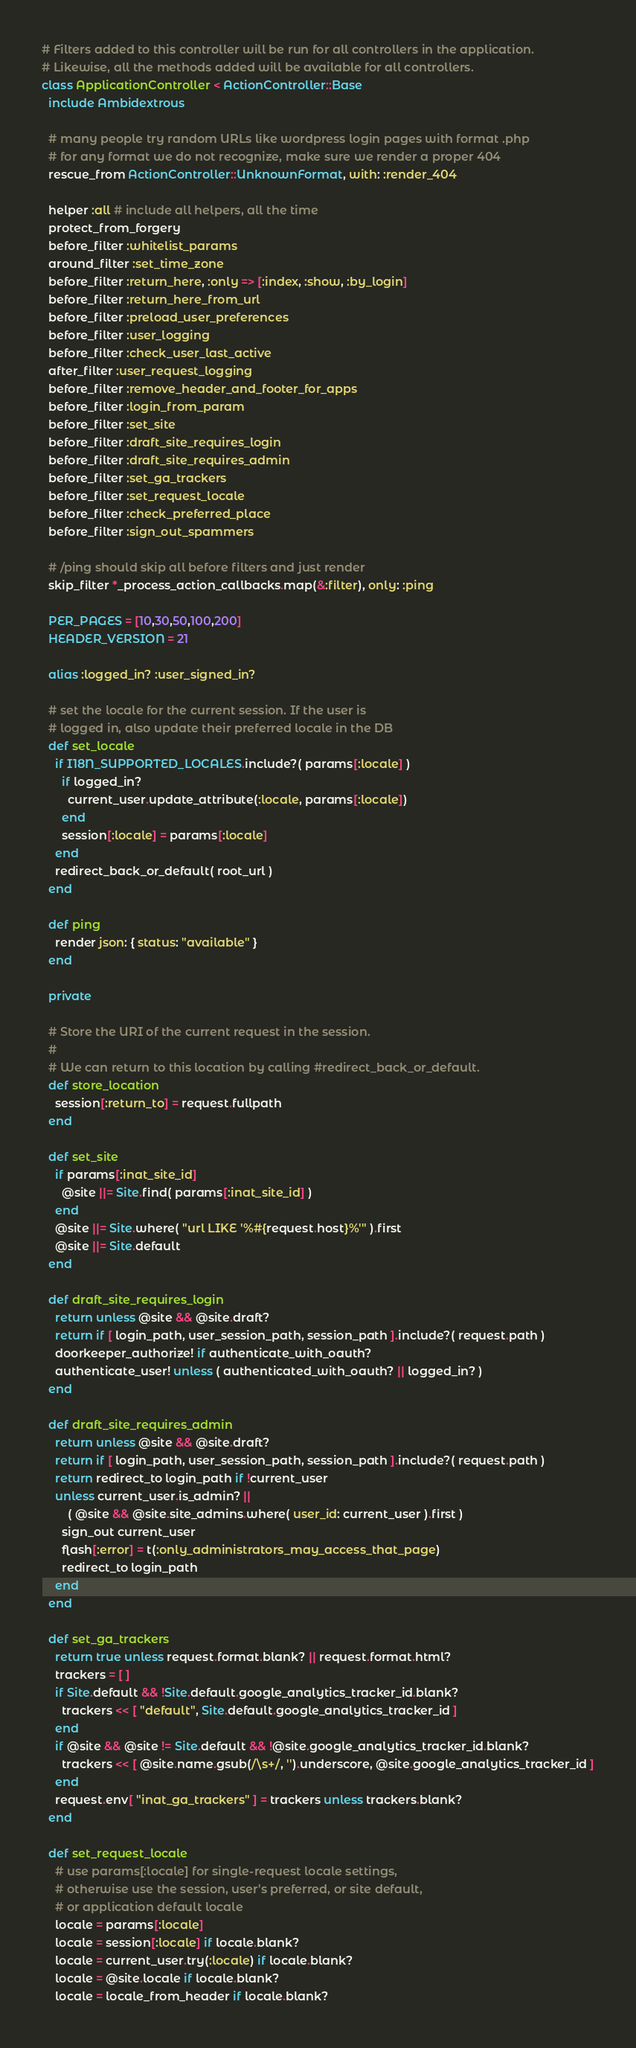Convert code to text. <code><loc_0><loc_0><loc_500><loc_500><_Ruby_># Filters added to this controller will be run for all controllers in the application.
# Likewise, all the methods added will be available for all controllers.
class ApplicationController < ActionController::Base
  include Ambidextrous

  # many people try random URLs like wordpress login pages with format .php
  # for any format we do not recognize, make sure we render a proper 404
  rescue_from ActionController::UnknownFormat, with: :render_404

  helper :all # include all helpers, all the time
  protect_from_forgery
  before_filter :whitelist_params
  around_filter :set_time_zone
  before_filter :return_here, :only => [:index, :show, :by_login]
  before_filter :return_here_from_url
  before_filter :preload_user_preferences
  before_filter :user_logging
  before_filter :check_user_last_active
  after_filter :user_request_logging
  before_filter :remove_header_and_footer_for_apps
  before_filter :login_from_param
  before_filter :set_site
  before_filter :draft_site_requires_login
  before_filter :draft_site_requires_admin
  before_filter :set_ga_trackers
  before_filter :set_request_locale
  before_filter :check_preferred_place
  before_filter :sign_out_spammers

  # /ping should skip all before filters and just render
  skip_filter *_process_action_callbacks.map(&:filter), only: :ping

  PER_PAGES = [10,30,50,100,200]
  HEADER_VERSION = 21
  
  alias :logged_in? :user_signed_in?

  # set the locale for the current session. If the user is
  # logged in, also update their preferred locale in the DB
  def set_locale
    if I18N_SUPPORTED_LOCALES.include?( params[:locale] )
      if logged_in?
        current_user.update_attribute(:locale, params[:locale])
      end
      session[:locale] = params[:locale]
    end
    redirect_back_or_default( root_url )
  end

  def ping
    render json: { status: "available" }
  end

  private

  # Store the URI of the current request in the session.
  #
  # We can return to this location by calling #redirect_back_or_default.
  def store_location
    session[:return_to] = request.fullpath
  end

  def set_site
    if params[:inat_site_id]
      @site ||= Site.find( params[:inat_site_id] )
    end
    @site ||= Site.where( "url LIKE '%#{request.host}%'" ).first
    @site ||= Site.default
  end

  def draft_site_requires_login
    return unless @site && @site.draft?
    return if [ login_path, user_session_path, session_path ].include?( request.path )
    doorkeeper_authorize! if authenticate_with_oauth?
    authenticate_user! unless ( authenticated_with_oauth? || logged_in? )
  end

  def draft_site_requires_admin
    return unless @site && @site.draft?
    return if [ login_path, user_session_path, session_path ].include?( request.path )
    return redirect_to login_path if !current_user
    unless current_user.is_admin? ||
        ( @site && @site.site_admins.where( user_id: current_user ).first )
      sign_out current_user
      flash[:error] = t(:only_administrators_may_access_that_page)
      redirect_to login_path
    end
  end

  def set_ga_trackers
    return true unless request.format.blank? || request.format.html?
    trackers = [ ]
    if Site.default && !Site.default.google_analytics_tracker_id.blank?
      trackers << [ "default", Site.default.google_analytics_tracker_id ]
    end
    if @site && @site != Site.default && !@site.google_analytics_tracker_id.blank?
      trackers << [ @site.name.gsub(/\s+/, '').underscore, @site.google_analytics_tracker_id ]
    end
    request.env[ "inat_ga_trackers" ] = trackers unless trackers.blank?
  end

  def set_request_locale
    # use params[:locale] for single-request locale settings,
    # otherwise use the session, user's preferred, or site default,
    # or application default locale
    locale = params[:locale]
    locale = session[:locale] if locale.blank?
    locale = current_user.try(:locale) if locale.blank?
    locale = @site.locale if locale.blank?
    locale = locale_from_header if locale.blank?</code> 